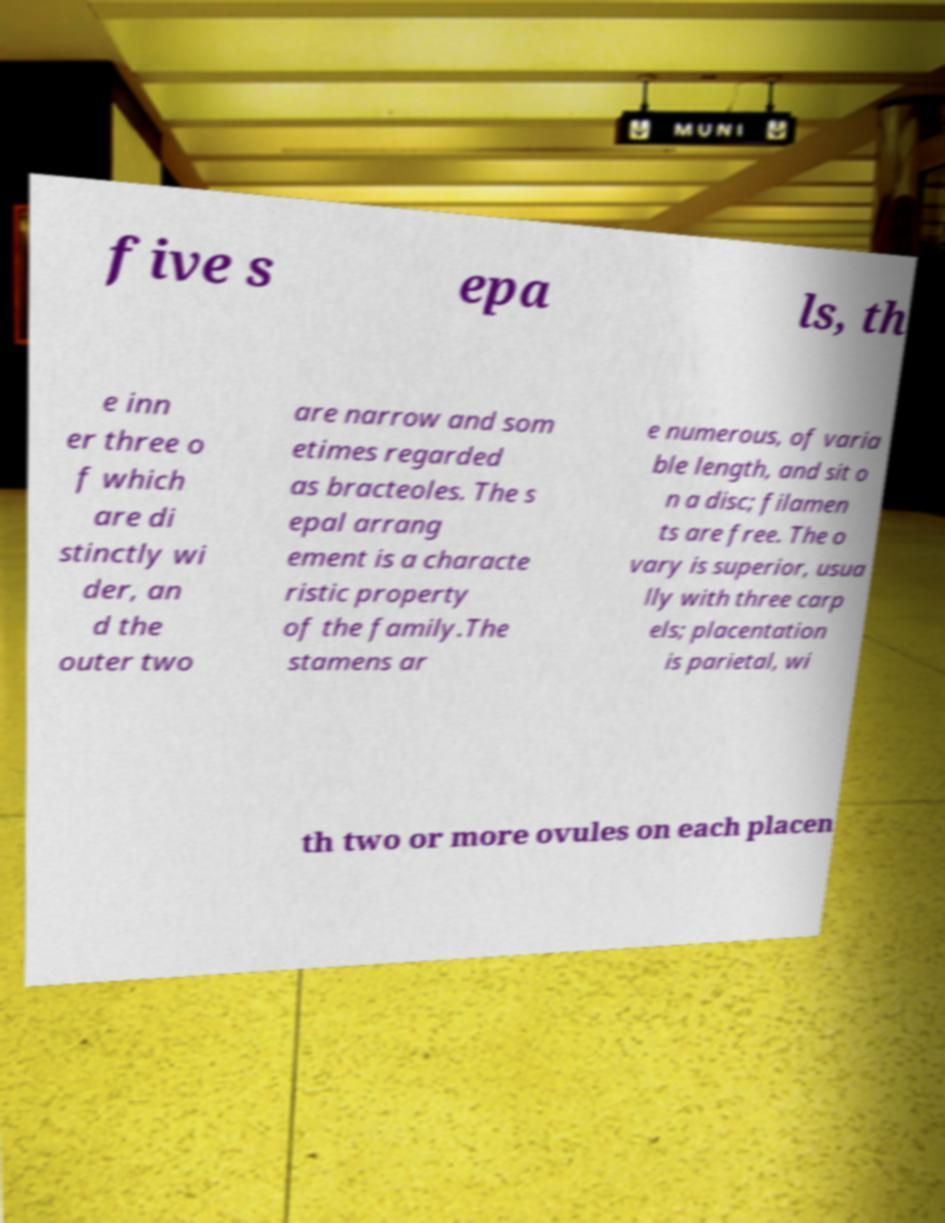Could you assist in decoding the text presented in this image and type it out clearly? five s epa ls, th e inn er three o f which are di stinctly wi der, an d the outer two are narrow and som etimes regarded as bracteoles. The s epal arrang ement is a characte ristic property of the family.The stamens ar e numerous, of varia ble length, and sit o n a disc; filamen ts are free. The o vary is superior, usua lly with three carp els; placentation is parietal, wi th two or more ovules on each placen 